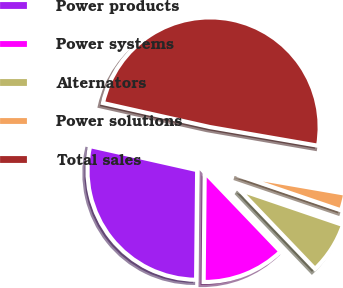Convert chart. <chart><loc_0><loc_0><loc_500><loc_500><pie_chart><fcel>Power products<fcel>Power systems<fcel>Alternators<fcel>Power solutions<fcel>Total sales<nl><fcel>28.36%<fcel>12.3%<fcel>7.63%<fcel>2.5%<fcel>49.21%<nl></chart> 